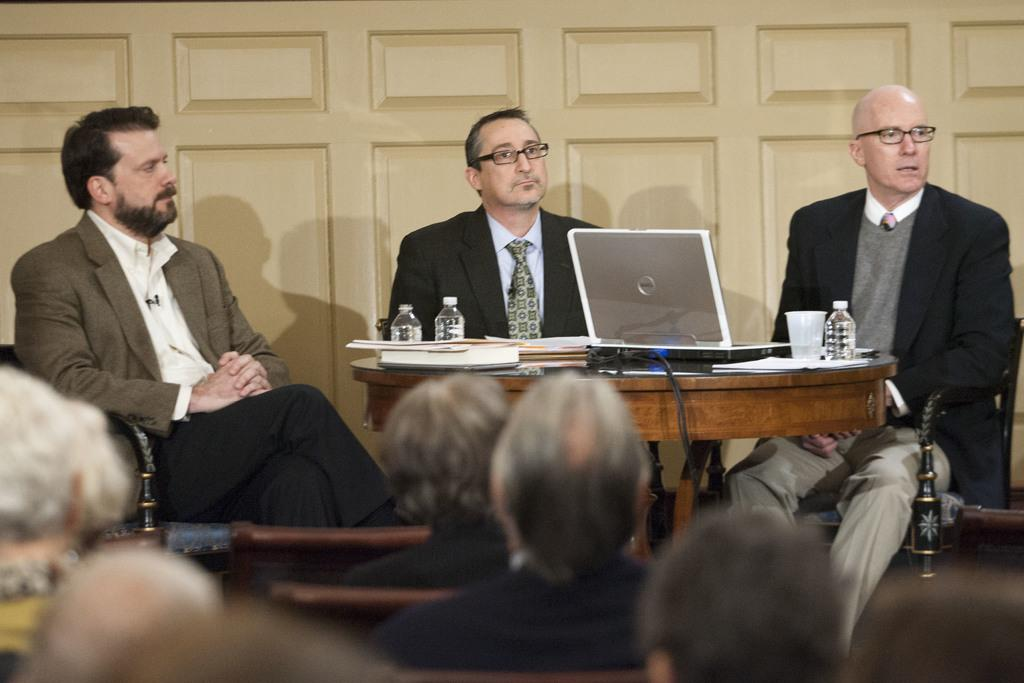What are the people in the image doing? The people in the image are sitting at the front and back. What is on the table in the image? There is a laptop, a glass, books, and bottles on the table. Can you describe the electronic device on the table? Yes, there is a laptop present on the table. What might the people be using the laptop for? It is not clear from the image what the people are using the laptop for. How many people are seated in the image? There are people seated at the front and back, but the exact number is not specified. What type of leaf is being used as a jam spreader in the image? There is no leaf or jam present in the image. How many beds are visible in the image? There are no beds visible in the image. 